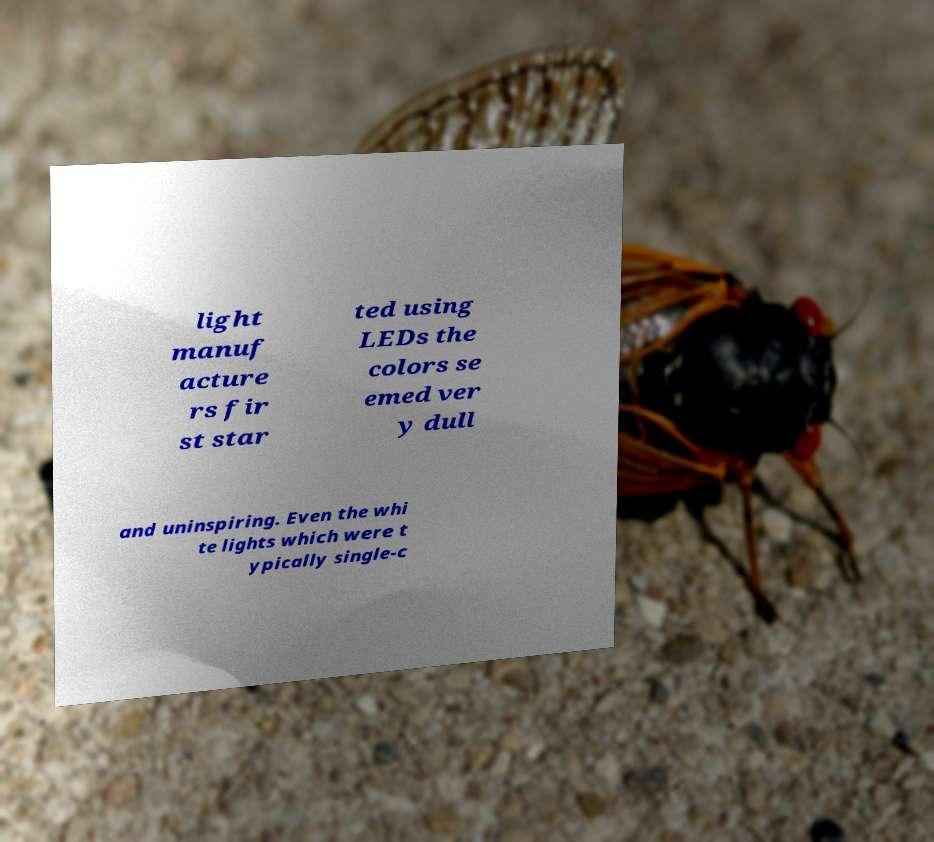Could you extract and type out the text from this image? light manuf acture rs fir st star ted using LEDs the colors se emed ver y dull and uninspiring. Even the whi te lights which were t ypically single-c 